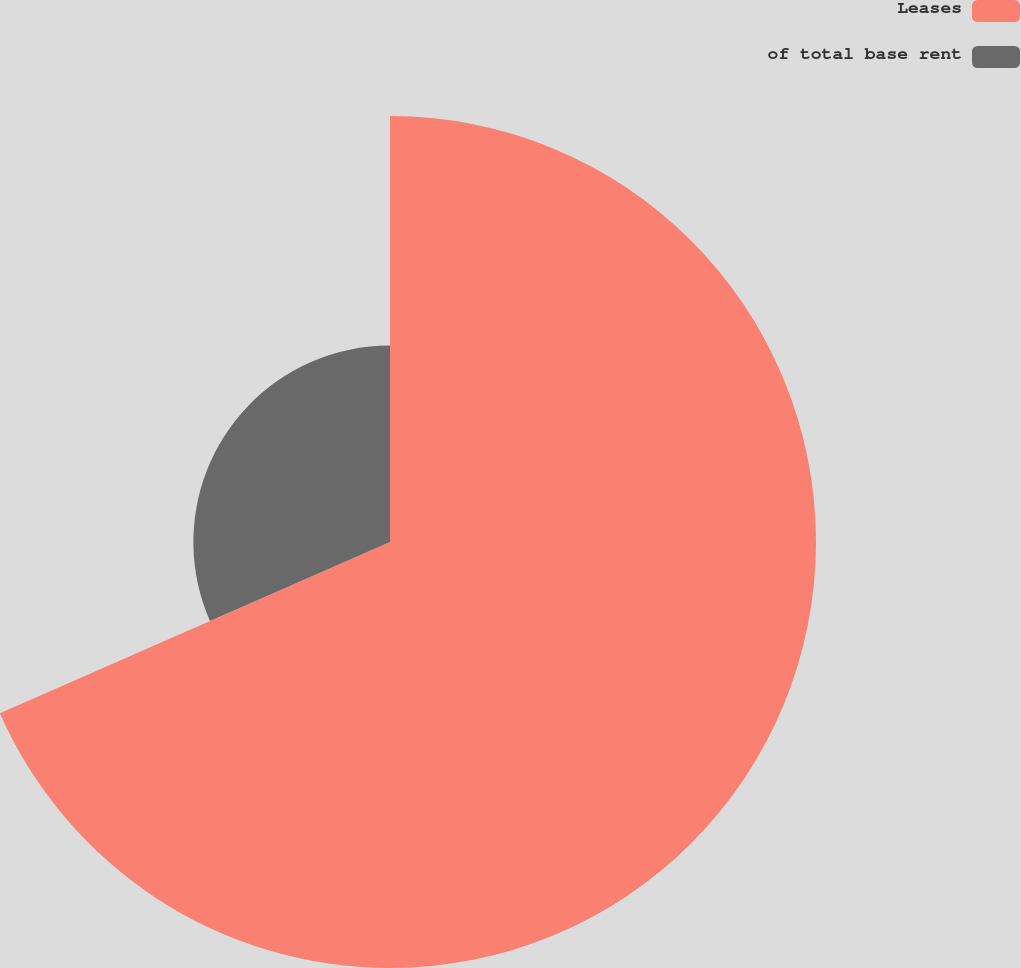Convert chart. <chart><loc_0><loc_0><loc_500><loc_500><pie_chart><fcel>Leases<fcel>of total base rent<nl><fcel>68.42%<fcel>31.58%<nl></chart> 